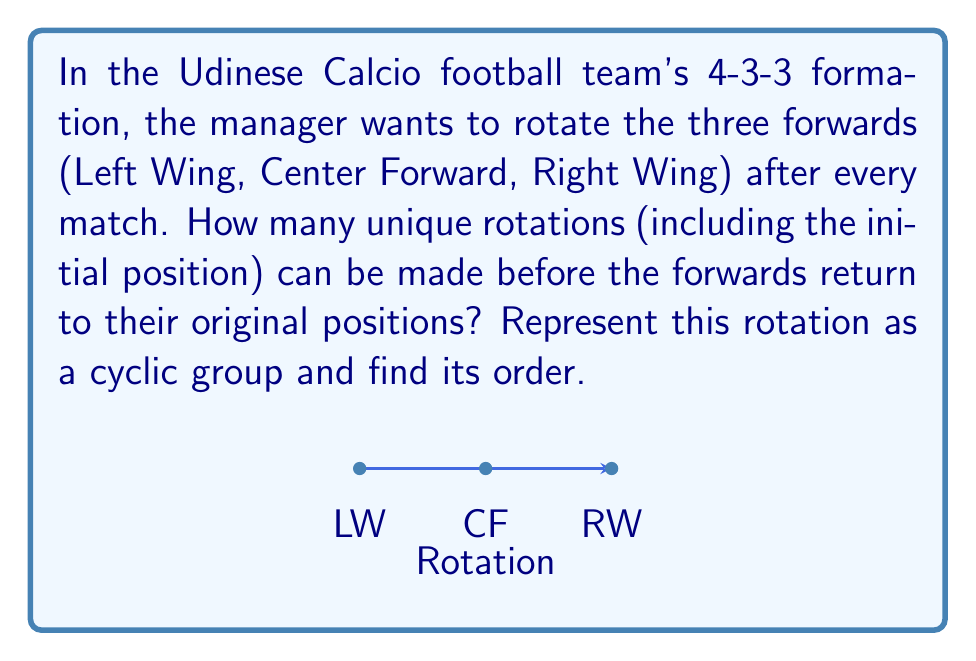What is the answer to this math problem? Let's approach this step-by-step:

1) First, we need to understand what the rotations look like:
   Initial: (LW, CF, RW)
   After 1 rotation: (RW, LW, CF)
   After 2 rotations: (CF, RW, LW)

2) We can represent this rotation as a permutation in cycle notation:
   $\sigma = (1 \; 3 \; 2)$, where 1 = LW, 2 = CF, 3 = RW

3) To find the order of this cyclic group, we need to determine how many times we need to apply this rotation before we get back to the initial position.

4) Mathematically, we're looking for the smallest positive integer $n$ such that $\sigma^n = e$ (the identity permutation).

5) We can see that:
   $\sigma^1 = (1 \; 3 \; 2)$
   $\sigma^2 = (1 \; 3 \; 2)(1 \; 3 \; 2) = (1 \; 2 \; 3)$
   $\sigma^3 = (1 \; 3 \; 2)(1 \; 2 \; 3) = (1)$ (identity)

6) Therefore, the order of this cyclic group is 3.

7) This means there are 3 unique rotations (including the initial position) before the forwards return to their original positions.
Answer: 3 